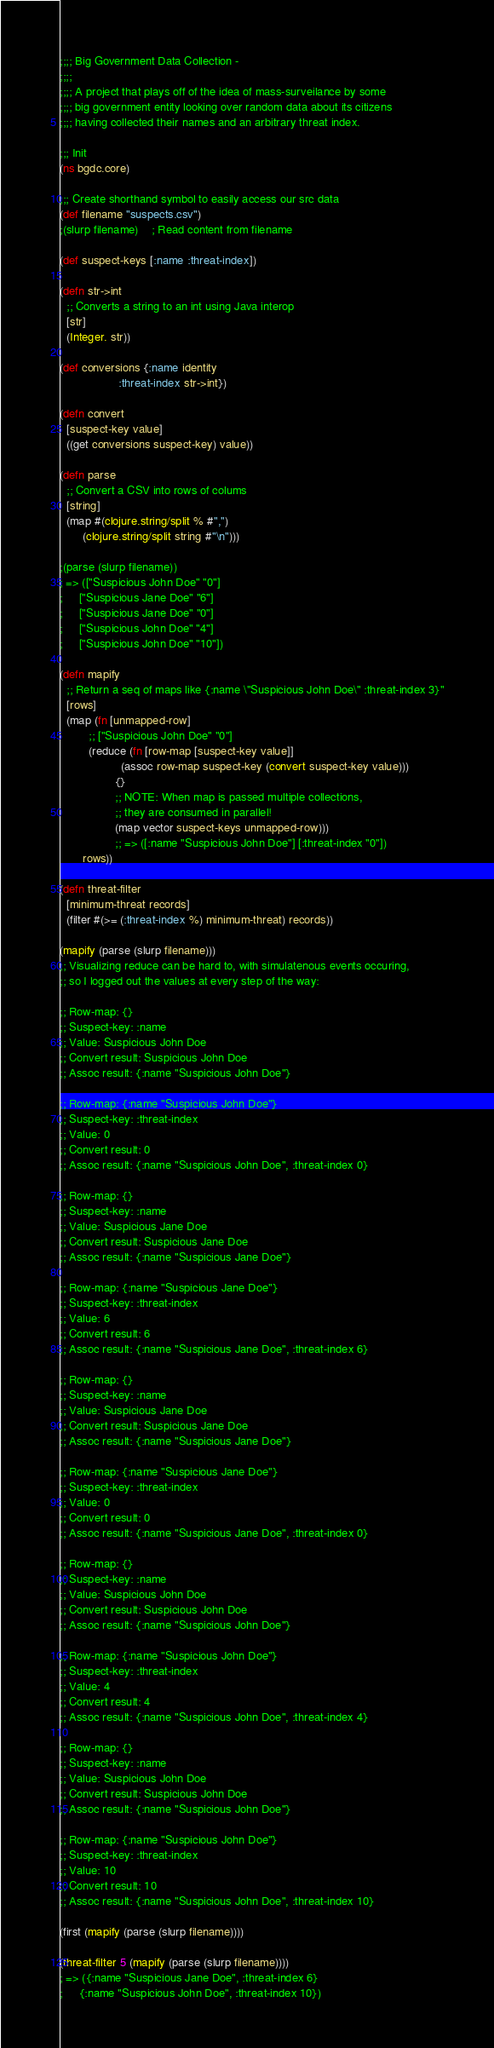Convert code to text. <code><loc_0><loc_0><loc_500><loc_500><_Clojure_>;;;; Big Government Data Collection -
;;;;
;;;; A project that plays off of the idea of mass-surveilance by some
;;;; big government entity looking over random data about its citizens
;;;; having collected their names and an arbitrary threat index.

;;; Init
(ns bgdc.core)

;;; Create shorthand symbol to easily access our src data
(def filename "suspects.csv")
;(slurp filename)    ; Read content from filename

(def suspect-keys [:name :threat-index])

(defn str->int
  ;; Converts a string to an int using Java interop
  [str]
  (Integer. str))

(def conversions {:name identity
                  :threat-index str->int})

(defn convert
  [suspect-key value]
  ((get conversions suspect-key) value))

(defn parse
  ;; Convert a CSV into rows of colums
  [string]
  (map #(clojure.string/split % #",")
       (clojure.string/split string #"\n")))

;(parse (slurp filename))
; => (["Suspicious John Doe" "0"]
;     ["Suspicious Jane Doe" "6"]
;     ["Suspicious Jane Doe" "0"]
;     ["Suspicious John Doe" "4"]
;     ["Suspicious John Doe" "10"])

(defn mapify
  ;; Return a seq of maps like {:name \"Suspicious John Doe\" :threat-index 3}"
  [rows]
  (map (fn [unmapped-row]
         ;; ["Suspicious John Doe" "0"]
         (reduce (fn [row-map [suspect-key value]]
                   (assoc row-map suspect-key (convert suspect-key value)))
                 {}
                 ;; NOTE: When map is passed multiple collections,
                 ;; they are consumed in parallel!
                 (map vector suspect-keys unmapped-row)))
                 ;; => ([:name "Suspicious John Doe"] [:threat-index "0"])
       rows))

(defn threat-filter
  [minimum-threat records]
  (filter #(>= (:threat-index %) minimum-threat) records))

(mapify (parse (slurp filename)))
;; Visualizing reduce can be hard to, with simulatenous events occuring,
;; so I logged out the values at every step of the way:

;; Row-map: {}
;; Suspect-key: :name
;; Value: Suspicious John Doe
;; Convert result: Suspicious John Doe
;; Assoc result: {:name "Suspicious John Doe"}

;; Row-map: {:name "Suspicious John Doe"}
;; Suspect-key: :threat-index
;; Value: 0
;; Convert result: 0
;; Assoc result: {:name "Suspicious John Doe", :threat-index 0}

;; Row-map: {}
;; Suspect-key: :name
;; Value: Suspicious Jane Doe
;; Convert result: Suspicious Jane Doe
;; Assoc result: {:name "Suspicious Jane Doe"}

;; Row-map: {:name "Suspicious Jane Doe"}
;; Suspect-key: :threat-index
;; Value: 6
;; Convert result: 6
;; Assoc result: {:name "Suspicious Jane Doe", :threat-index 6}

;; Row-map: {}
;; Suspect-key: :name
;; Value: Suspicious Jane Doe
;; Convert result: Suspicious Jane Doe
;; Assoc result: {:name "Suspicious Jane Doe"}

;; Row-map: {:name "Suspicious Jane Doe"}
;; Suspect-key: :threat-index
;; Value: 0
;; Convert result: 0
;; Assoc result: {:name "Suspicious Jane Doe", :threat-index 0}

;; Row-map: {}
;; Suspect-key: :name
;; Value: Suspicious John Doe
;; Convert result: Suspicious John Doe
;; Assoc result: {:name "Suspicious John Doe"}

;; Row-map: {:name "Suspicious John Doe"}
;; Suspect-key: :threat-index
;; Value: 4
;; Convert result: 4
;; Assoc result: {:name "Suspicious John Doe", :threat-index 4}

;; Row-map: {}
;; Suspect-key: :name
;; Value: Suspicious John Doe
;; Convert result: Suspicious John Doe
;; Assoc result: {:name "Suspicious John Doe"}

;; Row-map: {:name "Suspicious John Doe"}
;; Suspect-key: :threat-index
;; Value: 10
;; Convert result: 10
;; Assoc result: {:name "Suspicious John Doe", :threat-index 10}

(first (mapify (parse (slurp filename))))

(threat-filter 5 (mapify (parse (slurp filename))))
; => ({:name "Suspicious Jane Doe", :threat-index 6}
;     {:name "Suspicious John Doe", :threat-index 10})
</code> 